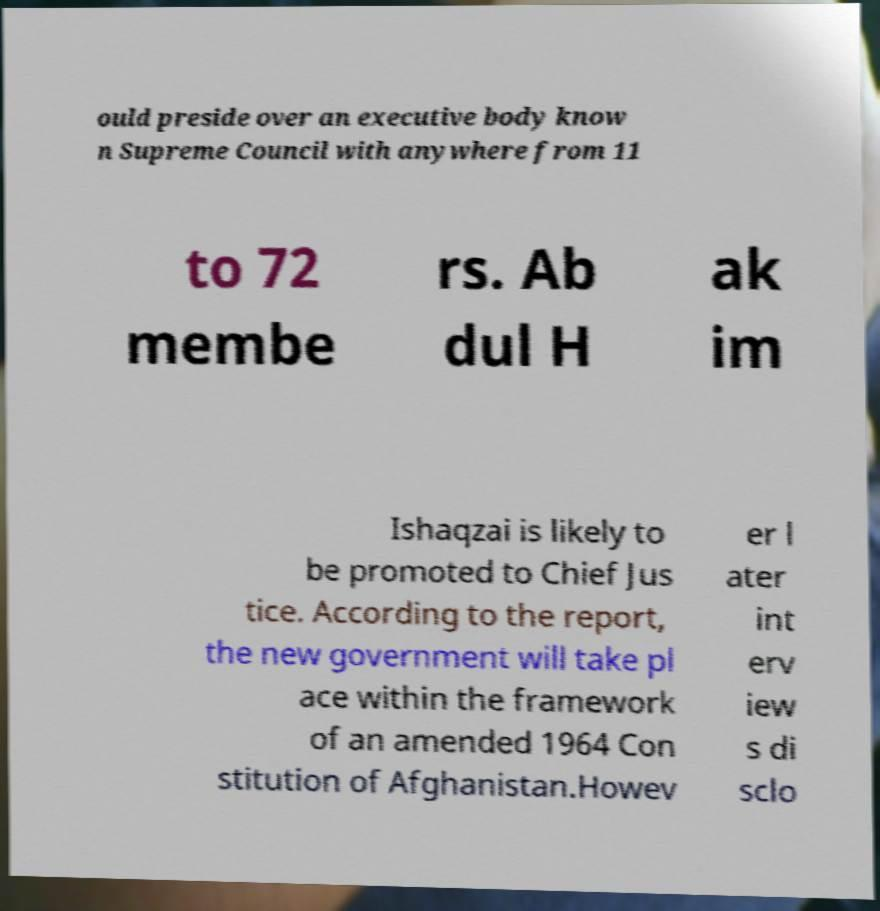Please identify and transcribe the text found in this image. ould preside over an executive body know n Supreme Council with anywhere from 11 to 72 membe rs. Ab dul H ak im Ishaqzai is likely to be promoted to Chief Jus tice. According to the report, the new government will take pl ace within the framework of an amended 1964 Con stitution of Afghanistan.Howev er l ater int erv iew s di sclo 